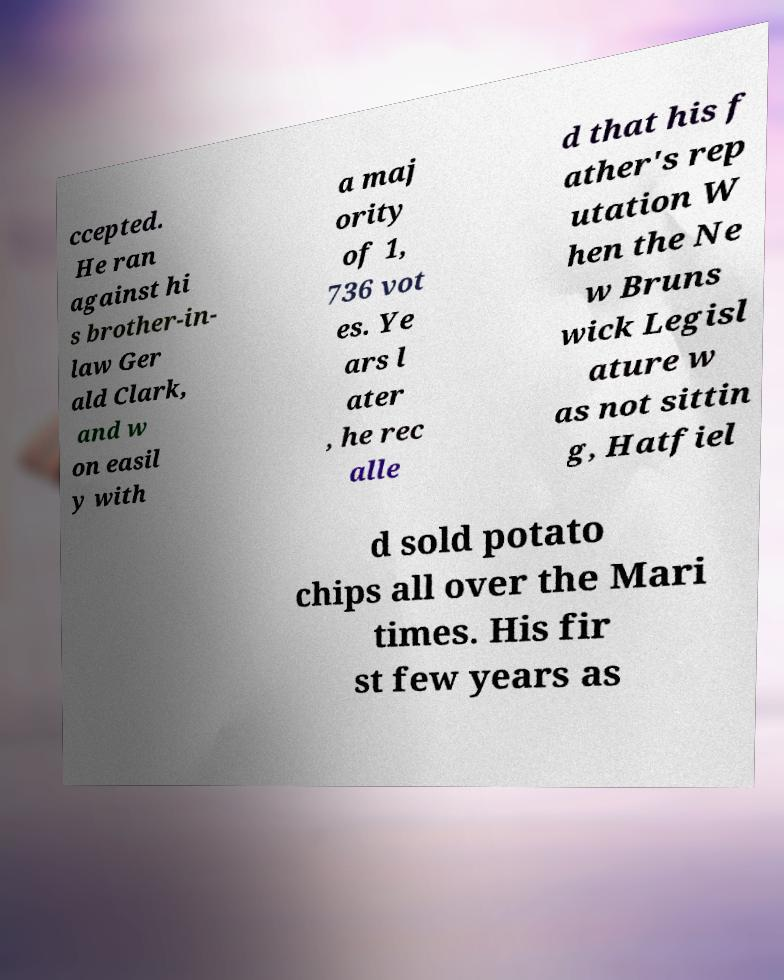Could you extract and type out the text from this image? ccepted. He ran against hi s brother-in- law Ger ald Clark, and w on easil y with a maj ority of 1, 736 vot es. Ye ars l ater , he rec alle d that his f ather's rep utation W hen the Ne w Bruns wick Legisl ature w as not sittin g, Hatfiel d sold potato chips all over the Mari times. His fir st few years as 